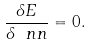Convert formula to latex. <formula><loc_0><loc_0><loc_500><loc_500>\frac { \delta E } { \delta \ n n } = 0 .</formula> 